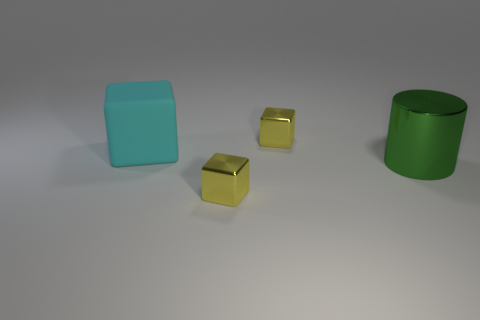Which objects in the image have a reflective surface? The two smaller cubes have a reflective surface, which can be identified by the way they mirror some of the light and objects around them. Their surfaces appear shiny, indicating that they are most likely made of a reflective material. 